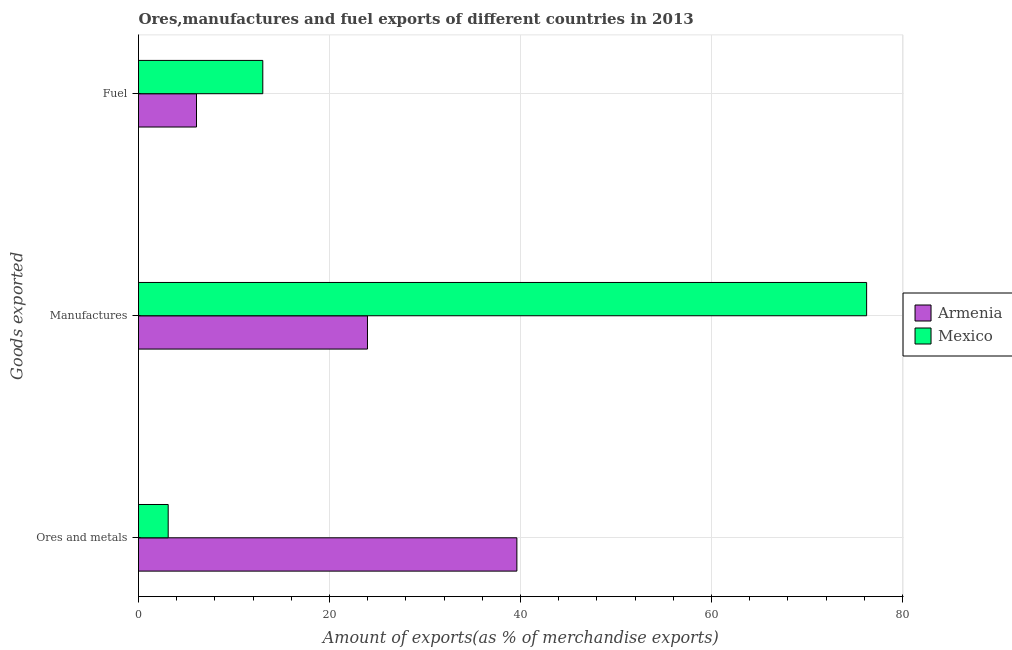How many groups of bars are there?
Ensure brevity in your answer.  3. Are the number of bars per tick equal to the number of legend labels?
Your answer should be very brief. Yes. Are the number of bars on each tick of the Y-axis equal?
Your answer should be compact. Yes. How many bars are there on the 2nd tick from the top?
Your answer should be compact. 2. What is the label of the 3rd group of bars from the top?
Provide a succinct answer. Ores and metals. What is the percentage of manufactures exports in Mexico?
Keep it short and to the point. 76.25. Across all countries, what is the maximum percentage of ores and metals exports?
Offer a terse response. 39.62. Across all countries, what is the minimum percentage of ores and metals exports?
Keep it short and to the point. 3.11. In which country was the percentage of fuel exports maximum?
Provide a succinct answer. Mexico. In which country was the percentage of fuel exports minimum?
Provide a succinct answer. Armenia. What is the total percentage of ores and metals exports in the graph?
Offer a very short reply. 42.73. What is the difference between the percentage of manufactures exports in Mexico and that in Armenia?
Your answer should be compact. 52.27. What is the difference between the percentage of fuel exports in Mexico and the percentage of manufactures exports in Armenia?
Give a very brief answer. -10.96. What is the average percentage of fuel exports per country?
Your answer should be very brief. 9.54. What is the difference between the percentage of ores and metals exports and percentage of fuel exports in Mexico?
Offer a terse response. -9.91. In how many countries, is the percentage of manufactures exports greater than 44 %?
Give a very brief answer. 1. What is the ratio of the percentage of manufactures exports in Armenia to that in Mexico?
Provide a short and direct response. 0.31. Is the difference between the percentage of manufactures exports in Armenia and Mexico greater than the difference between the percentage of fuel exports in Armenia and Mexico?
Offer a very short reply. No. What is the difference between the highest and the second highest percentage of fuel exports?
Make the answer very short. 6.94. What is the difference between the highest and the lowest percentage of fuel exports?
Offer a very short reply. 6.94. What does the 1st bar from the top in Ores and metals represents?
Provide a short and direct response. Mexico. Is it the case that in every country, the sum of the percentage of ores and metals exports and percentage of manufactures exports is greater than the percentage of fuel exports?
Make the answer very short. Yes. Are all the bars in the graph horizontal?
Your answer should be very brief. Yes. Are the values on the major ticks of X-axis written in scientific E-notation?
Make the answer very short. No. Does the graph contain any zero values?
Offer a terse response. No. Where does the legend appear in the graph?
Offer a terse response. Center right. How many legend labels are there?
Your response must be concise. 2. How are the legend labels stacked?
Provide a short and direct response. Vertical. What is the title of the graph?
Give a very brief answer. Ores,manufactures and fuel exports of different countries in 2013. Does "Palau" appear as one of the legend labels in the graph?
Your answer should be compact. No. What is the label or title of the X-axis?
Offer a terse response. Amount of exports(as % of merchandise exports). What is the label or title of the Y-axis?
Ensure brevity in your answer.  Goods exported. What is the Amount of exports(as % of merchandise exports) of Armenia in Ores and metals?
Offer a very short reply. 39.62. What is the Amount of exports(as % of merchandise exports) of Mexico in Ores and metals?
Your answer should be compact. 3.11. What is the Amount of exports(as % of merchandise exports) in Armenia in Manufactures?
Make the answer very short. 23.98. What is the Amount of exports(as % of merchandise exports) in Mexico in Manufactures?
Provide a short and direct response. 76.25. What is the Amount of exports(as % of merchandise exports) in Armenia in Fuel?
Make the answer very short. 6.07. What is the Amount of exports(as % of merchandise exports) of Mexico in Fuel?
Offer a very short reply. 13.02. Across all Goods exported, what is the maximum Amount of exports(as % of merchandise exports) of Armenia?
Make the answer very short. 39.62. Across all Goods exported, what is the maximum Amount of exports(as % of merchandise exports) in Mexico?
Keep it short and to the point. 76.25. Across all Goods exported, what is the minimum Amount of exports(as % of merchandise exports) of Armenia?
Your response must be concise. 6.07. Across all Goods exported, what is the minimum Amount of exports(as % of merchandise exports) in Mexico?
Keep it short and to the point. 3.11. What is the total Amount of exports(as % of merchandise exports) of Armenia in the graph?
Offer a terse response. 69.67. What is the total Amount of exports(as % of merchandise exports) in Mexico in the graph?
Ensure brevity in your answer.  92.37. What is the difference between the Amount of exports(as % of merchandise exports) in Armenia in Ores and metals and that in Manufactures?
Your answer should be very brief. 15.65. What is the difference between the Amount of exports(as % of merchandise exports) of Mexico in Ores and metals and that in Manufactures?
Provide a succinct answer. -73.14. What is the difference between the Amount of exports(as % of merchandise exports) of Armenia in Ores and metals and that in Fuel?
Provide a succinct answer. 33.55. What is the difference between the Amount of exports(as % of merchandise exports) of Mexico in Ores and metals and that in Fuel?
Ensure brevity in your answer.  -9.91. What is the difference between the Amount of exports(as % of merchandise exports) of Armenia in Manufactures and that in Fuel?
Offer a terse response. 17.91. What is the difference between the Amount of exports(as % of merchandise exports) of Mexico in Manufactures and that in Fuel?
Provide a succinct answer. 63.23. What is the difference between the Amount of exports(as % of merchandise exports) of Armenia in Ores and metals and the Amount of exports(as % of merchandise exports) of Mexico in Manufactures?
Make the answer very short. -36.63. What is the difference between the Amount of exports(as % of merchandise exports) in Armenia in Ores and metals and the Amount of exports(as % of merchandise exports) in Mexico in Fuel?
Offer a terse response. 26.61. What is the difference between the Amount of exports(as % of merchandise exports) in Armenia in Manufactures and the Amount of exports(as % of merchandise exports) in Mexico in Fuel?
Offer a terse response. 10.96. What is the average Amount of exports(as % of merchandise exports) of Armenia per Goods exported?
Give a very brief answer. 23.22. What is the average Amount of exports(as % of merchandise exports) in Mexico per Goods exported?
Make the answer very short. 30.79. What is the difference between the Amount of exports(as % of merchandise exports) of Armenia and Amount of exports(as % of merchandise exports) of Mexico in Ores and metals?
Your answer should be very brief. 36.52. What is the difference between the Amount of exports(as % of merchandise exports) in Armenia and Amount of exports(as % of merchandise exports) in Mexico in Manufactures?
Ensure brevity in your answer.  -52.27. What is the difference between the Amount of exports(as % of merchandise exports) of Armenia and Amount of exports(as % of merchandise exports) of Mexico in Fuel?
Your answer should be very brief. -6.94. What is the ratio of the Amount of exports(as % of merchandise exports) of Armenia in Ores and metals to that in Manufactures?
Your answer should be very brief. 1.65. What is the ratio of the Amount of exports(as % of merchandise exports) in Mexico in Ores and metals to that in Manufactures?
Make the answer very short. 0.04. What is the ratio of the Amount of exports(as % of merchandise exports) of Armenia in Ores and metals to that in Fuel?
Your answer should be compact. 6.52. What is the ratio of the Amount of exports(as % of merchandise exports) of Mexico in Ores and metals to that in Fuel?
Keep it short and to the point. 0.24. What is the ratio of the Amount of exports(as % of merchandise exports) of Armenia in Manufactures to that in Fuel?
Provide a short and direct response. 3.95. What is the ratio of the Amount of exports(as % of merchandise exports) of Mexico in Manufactures to that in Fuel?
Offer a terse response. 5.86. What is the difference between the highest and the second highest Amount of exports(as % of merchandise exports) of Armenia?
Your response must be concise. 15.65. What is the difference between the highest and the second highest Amount of exports(as % of merchandise exports) of Mexico?
Give a very brief answer. 63.23. What is the difference between the highest and the lowest Amount of exports(as % of merchandise exports) of Armenia?
Provide a succinct answer. 33.55. What is the difference between the highest and the lowest Amount of exports(as % of merchandise exports) in Mexico?
Your answer should be compact. 73.14. 